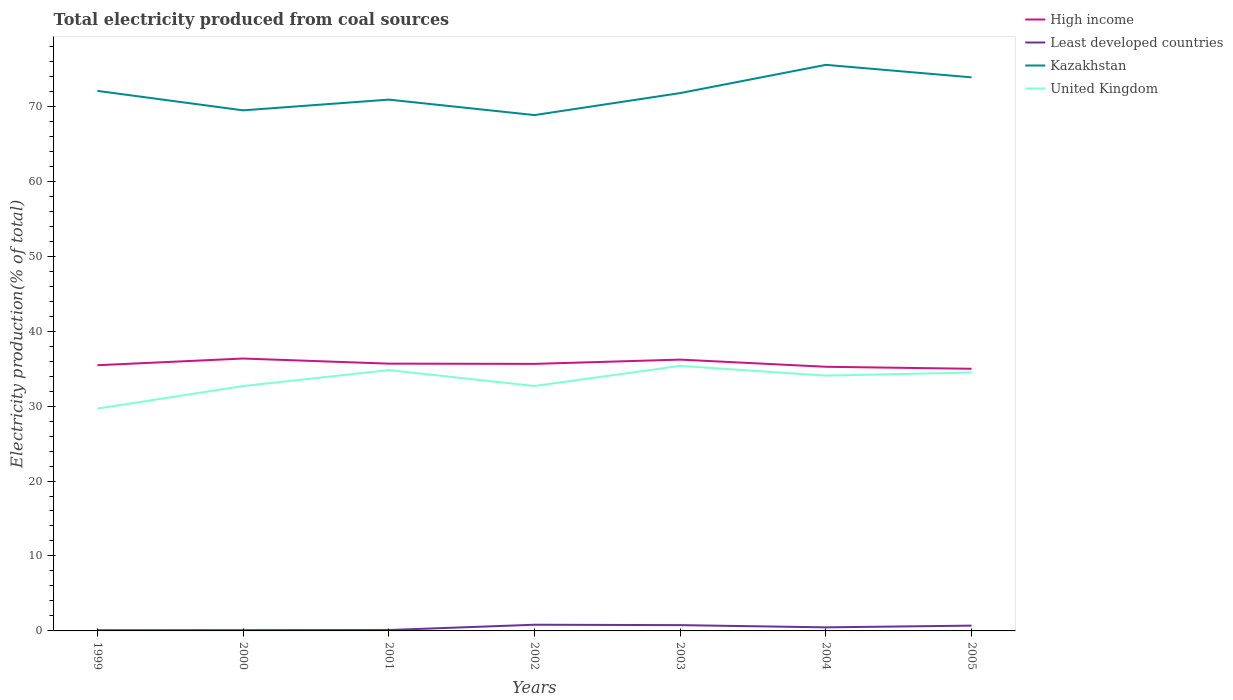How many different coloured lines are there?
Provide a short and direct response. 4. Across all years, what is the maximum total electricity produced in Kazakhstan?
Give a very brief answer. 68.82. What is the total total electricity produced in Kazakhstan in the graph?
Offer a terse response. -0.87. What is the difference between the highest and the second highest total electricity produced in Kazakhstan?
Provide a short and direct response. 6.7. What is the difference between two consecutive major ticks on the Y-axis?
Ensure brevity in your answer.  10. Does the graph contain any zero values?
Keep it short and to the point. No. How many legend labels are there?
Keep it short and to the point. 4. What is the title of the graph?
Ensure brevity in your answer.  Total electricity produced from coal sources. Does "Mozambique" appear as one of the legend labels in the graph?
Ensure brevity in your answer.  No. What is the label or title of the X-axis?
Your answer should be very brief. Years. What is the Electricity production(% of total) of High income in 1999?
Make the answer very short. 35.45. What is the Electricity production(% of total) in Least developed countries in 1999?
Your answer should be compact. 0.1. What is the Electricity production(% of total) in Kazakhstan in 1999?
Your answer should be compact. 72.05. What is the Electricity production(% of total) in United Kingdom in 1999?
Your answer should be compact. 29.66. What is the Electricity production(% of total) in High income in 2000?
Your answer should be compact. 36.34. What is the Electricity production(% of total) of Least developed countries in 2000?
Your answer should be compact. 0.1. What is the Electricity production(% of total) of Kazakhstan in 2000?
Give a very brief answer. 69.45. What is the Electricity production(% of total) in United Kingdom in 2000?
Provide a short and direct response. 32.67. What is the Electricity production(% of total) in High income in 2001?
Keep it short and to the point. 35.66. What is the Electricity production(% of total) of Least developed countries in 2001?
Make the answer very short. 0.12. What is the Electricity production(% of total) in Kazakhstan in 2001?
Your answer should be very brief. 70.88. What is the Electricity production(% of total) in United Kingdom in 2001?
Your response must be concise. 34.8. What is the Electricity production(% of total) of High income in 2002?
Your answer should be very brief. 35.63. What is the Electricity production(% of total) in Least developed countries in 2002?
Provide a succinct answer. 0.83. What is the Electricity production(% of total) of Kazakhstan in 2002?
Make the answer very short. 68.82. What is the Electricity production(% of total) in United Kingdom in 2002?
Ensure brevity in your answer.  32.68. What is the Electricity production(% of total) in High income in 2003?
Ensure brevity in your answer.  36.2. What is the Electricity production(% of total) in Least developed countries in 2003?
Offer a very short reply. 0.77. What is the Electricity production(% of total) in Kazakhstan in 2003?
Your response must be concise. 71.75. What is the Electricity production(% of total) of United Kingdom in 2003?
Your answer should be compact. 35.36. What is the Electricity production(% of total) of High income in 2004?
Offer a terse response. 35.24. What is the Electricity production(% of total) of Least developed countries in 2004?
Offer a very short reply. 0.48. What is the Electricity production(% of total) of Kazakhstan in 2004?
Provide a short and direct response. 75.52. What is the Electricity production(% of total) in United Kingdom in 2004?
Your response must be concise. 34.06. What is the Electricity production(% of total) of High income in 2005?
Keep it short and to the point. 34.97. What is the Electricity production(% of total) in Least developed countries in 2005?
Your answer should be compact. 0.71. What is the Electricity production(% of total) of Kazakhstan in 2005?
Your answer should be very brief. 73.85. What is the Electricity production(% of total) of United Kingdom in 2005?
Offer a terse response. 34.48. Across all years, what is the maximum Electricity production(% of total) in High income?
Ensure brevity in your answer.  36.34. Across all years, what is the maximum Electricity production(% of total) of Least developed countries?
Your answer should be very brief. 0.83. Across all years, what is the maximum Electricity production(% of total) of Kazakhstan?
Make the answer very short. 75.52. Across all years, what is the maximum Electricity production(% of total) in United Kingdom?
Give a very brief answer. 35.36. Across all years, what is the minimum Electricity production(% of total) in High income?
Ensure brevity in your answer.  34.97. Across all years, what is the minimum Electricity production(% of total) of Least developed countries?
Ensure brevity in your answer.  0.1. Across all years, what is the minimum Electricity production(% of total) in Kazakhstan?
Your answer should be very brief. 68.82. Across all years, what is the minimum Electricity production(% of total) of United Kingdom?
Your answer should be very brief. 29.66. What is the total Electricity production(% of total) of High income in the graph?
Keep it short and to the point. 249.48. What is the total Electricity production(% of total) of Least developed countries in the graph?
Make the answer very short. 3.1. What is the total Electricity production(% of total) of Kazakhstan in the graph?
Your answer should be compact. 502.33. What is the total Electricity production(% of total) in United Kingdom in the graph?
Give a very brief answer. 233.7. What is the difference between the Electricity production(% of total) in High income in 1999 and that in 2000?
Offer a terse response. -0.89. What is the difference between the Electricity production(% of total) of Least developed countries in 1999 and that in 2000?
Give a very brief answer. -0.01. What is the difference between the Electricity production(% of total) of Kazakhstan in 1999 and that in 2000?
Your answer should be very brief. 2.6. What is the difference between the Electricity production(% of total) of United Kingdom in 1999 and that in 2000?
Offer a very short reply. -3.01. What is the difference between the Electricity production(% of total) of High income in 1999 and that in 2001?
Give a very brief answer. -0.21. What is the difference between the Electricity production(% of total) of Least developed countries in 1999 and that in 2001?
Offer a very short reply. -0.02. What is the difference between the Electricity production(% of total) of Kazakhstan in 1999 and that in 2001?
Offer a very short reply. 1.17. What is the difference between the Electricity production(% of total) of United Kingdom in 1999 and that in 2001?
Ensure brevity in your answer.  -5.13. What is the difference between the Electricity production(% of total) of High income in 1999 and that in 2002?
Provide a succinct answer. -0.18. What is the difference between the Electricity production(% of total) in Least developed countries in 1999 and that in 2002?
Keep it short and to the point. -0.73. What is the difference between the Electricity production(% of total) of Kazakhstan in 1999 and that in 2002?
Your response must be concise. 3.23. What is the difference between the Electricity production(% of total) of United Kingdom in 1999 and that in 2002?
Your answer should be very brief. -3.02. What is the difference between the Electricity production(% of total) in High income in 1999 and that in 2003?
Your answer should be compact. -0.75. What is the difference between the Electricity production(% of total) in Least developed countries in 1999 and that in 2003?
Your answer should be compact. -0.68. What is the difference between the Electricity production(% of total) in Kazakhstan in 1999 and that in 2003?
Make the answer very short. 0.29. What is the difference between the Electricity production(% of total) in United Kingdom in 1999 and that in 2003?
Provide a succinct answer. -5.7. What is the difference between the Electricity production(% of total) in High income in 1999 and that in 2004?
Keep it short and to the point. 0.21. What is the difference between the Electricity production(% of total) of Least developed countries in 1999 and that in 2004?
Provide a short and direct response. -0.38. What is the difference between the Electricity production(% of total) of Kazakhstan in 1999 and that in 2004?
Your answer should be very brief. -3.47. What is the difference between the Electricity production(% of total) of United Kingdom in 1999 and that in 2004?
Provide a succinct answer. -4.4. What is the difference between the Electricity production(% of total) of High income in 1999 and that in 2005?
Your answer should be very brief. 0.48. What is the difference between the Electricity production(% of total) of Least developed countries in 1999 and that in 2005?
Your answer should be very brief. -0.61. What is the difference between the Electricity production(% of total) in Kazakhstan in 1999 and that in 2005?
Offer a terse response. -1.81. What is the difference between the Electricity production(% of total) in United Kingdom in 1999 and that in 2005?
Your answer should be compact. -4.82. What is the difference between the Electricity production(% of total) in High income in 2000 and that in 2001?
Your answer should be very brief. 0.68. What is the difference between the Electricity production(% of total) in Least developed countries in 2000 and that in 2001?
Make the answer very short. -0.02. What is the difference between the Electricity production(% of total) of Kazakhstan in 2000 and that in 2001?
Offer a very short reply. -1.43. What is the difference between the Electricity production(% of total) of United Kingdom in 2000 and that in 2001?
Your answer should be very brief. -2.13. What is the difference between the Electricity production(% of total) in High income in 2000 and that in 2002?
Give a very brief answer. 0.71. What is the difference between the Electricity production(% of total) of Least developed countries in 2000 and that in 2002?
Your answer should be compact. -0.72. What is the difference between the Electricity production(% of total) of Kazakhstan in 2000 and that in 2002?
Ensure brevity in your answer.  0.63. What is the difference between the Electricity production(% of total) in United Kingdom in 2000 and that in 2002?
Provide a short and direct response. -0.01. What is the difference between the Electricity production(% of total) in High income in 2000 and that in 2003?
Offer a very short reply. 0.14. What is the difference between the Electricity production(% of total) in Least developed countries in 2000 and that in 2003?
Your answer should be compact. -0.67. What is the difference between the Electricity production(% of total) of Kazakhstan in 2000 and that in 2003?
Provide a succinct answer. -2.3. What is the difference between the Electricity production(% of total) in United Kingdom in 2000 and that in 2003?
Make the answer very short. -2.69. What is the difference between the Electricity production(% of total) of High income in 2000 and that in 2004?
Make the answer very short. 1.1. What is the difference between the Electricity production(% of total) of Least developed countries in 2000 and that in 2004?
Make the answer very short. -0.38. What is the difference between the Electricity production(% of total) in Kazakhstan in 2000 and that in 2004?
Provide a succinct answer. -6.07. What is the difference between the Electricity production(% of total) in United Kingdom in 2000 and that in 2004?
Provide a short and direct response. -1.39. What is the difference between the Electricity production(% of total) in High income in 2000 and that in 2005?
Your answer should be very brief. 1.37. What is the difference between the Electricity production(% of total) of Least developed countries in 2000 and that in 2005?
Provide a succinct answer. -0.61. What is the difference between the Electricity production(% of total) of Kazakhstan in 2000 and that in 2005?
Provide a succinct answer. -4.4. What is the difference between the Electricity production(% of total) in United Kingdom in 2000 and that in 2005?
Make the answer very short. -1.81. What is the difference between the Electricity production(% of total) of High income in 2001 and that in 2002?
Provide a succinct answer. 0.03. What is the difference between the Electricity production(% of total) of Least developed countries in 2001 and that in 2002?
Provide a short and direct response. -0.71. What is the difference between the Electricity production(% of total) in Kazakhstan in 2001 and that in 2002?
Provide a succinct answer. 2.06. What is the difference between the Electricity production(% of total) in United Kingdom in 2001 and that in 2002?
Make the answer very short. 2.12. What is the difference between the Electricity production(% of total) of High income in 2001 and that in 2003?
Give a very brief answer. -0.54. What is the difference between the Electricity production(% of total) of Least developed countries in 2001 and that in 2003?
Give a very brief answer. -0.65. What is the difference between the Electricity production(% of total) of Kazakhstan in 2001 and that in 2003?
Ensure brevity in your answer.  -0.87. What is the difference between the Electricity production(% of total) in United Kingdom in 2001 and that in 2003?
Ensure brevity in your answer.  -0.56. What is the difference between the Electricity production(% of total) of High income in 2001 and that in 2004?
Offer a terse response. 0.42. What is the difference between the Electricity production(% of total) in Least developed countries in 2001 and that in 2004?
Give a very brief answer. -0.36. What is the difference between the Electricity production(% of total) in Kazakhstan in 2001 and that in 2004?
Ensure brevity in your answer.  -4.64. What is the difference between the Electricity production(% of total) in United Kingdom in 2001 and that in 2004?
Ensure brevity in your answer.  0.74. What is the difference between the Electricity production(% of total) in High income in 2001 and that in 2005?
Offer a very short reply. 0.69. What is the difference between the Electricity production(% of total) in Least developed countries in 2001 and that in 2005?
Your answer should be compact. -0.59. What is the difference between the Electricity production(% of total) of Kazakhstan in 2001 and that in 2005?
Your answer should be very brief. -2.97. What is the difference between the Electricity production(% of total) of United Kingdom in 2001 and that in 2005?
Provide a succinct answer. 0.32. What is the difference between the Electricity production(% of total) of High income in 2002 and that in 2003?
Offer a terse response. -0.57. What is the difference between the Electricity production(% of total) in Least developed countries in 2002 and that in 2003?
Keep it short and to the point. 0.05. What is the difference between the Electricity production(% of total) in Kazakhstan in 2002 and that in 2003?
Give a very brief answer. -2.93. What is the difference between the Electricity production(% of total) of United Kingdom in 2002 and that in 2003?
Make the answer very short. -2.68. What is the difference between the Electricity production(% of total) in High income in 2002 and that in 2004?
Offer a terse response. 0.39. What is the difference between the Electricity production(% of total) in Least developed countries in 2002 and that in 2004?
Your answer should be very brief. 0.35. What is the difference between the Electricity production(% of total) of Kazakhstan in 2002 and that in 2004?
Ensure brevity in your answer.  -6.7. What is the difference between the Electricity production(% of total) in United Kingdom in 2002 and that in 2004?
Make the answer very short. -1.38. What is the difference between the Electricity production(% of total) in High income in 2002 and that in 2005?
Make the answer very short. 0.66. What is the difference between the Electricity production(% of total) in Least developed countries in 2002 and that in 2005?
Make the answer very short. 0.12. What is the difference between the Electricity production(% of total) in Kazakhstan in 2002 and that in 2005?
Offer a very short reply. -5.03. What is the difference between the Electricity production(% of total) of United Kingdom in 2002 and that in 2005?
Your response must be concise. -1.8. What is the difference between the Electricity production(% of total) of High income in 2003 and that in 2004?
Your answer should be very brief. 0.95. What is the difference between the Electricity production(% of total) in Least developed countries in 2003 and that in 2004?
Provide a short and direct response. 0.3. What is the difference between the Electricity production(% of total) in Kazakhstan in 2003 and that in 2004?
Your answer should be very brief. -3.77. What is the difference between the Electricity production(% of total) of United Kingdom in 2003 and that in 2004?
Your response must be concise. 1.3. What is the difference between the Electricity production(% of total) of High income in 2003 and that in 2005?
Provide a short and direct response. 1.22. What is the difference between the Electricity production(% of total) of Least developed countries in 2003 and that in 2005?
Offer a very short reply. 0.07. What is the difference between the Electricity production(% of total) of Kazakhstan in 2003 and that in 2005?
Make the answer very short. -2.1. What is the difference between the Electricity production(% of total) in United Kingdom in 2003 and that in 2005?
Provide a short and direct response. 0.88. What is the difference between the Electricity production(% of total) in High income in 2004 and that in 2005?
Provide a short and direct response. 0.27. What is the difference between the Electricity production(% of total) in Least developed countries in 2004 and that in 2005?
Offer a terse response. -0.23. What is the difference between the Electricity production(% of total) of Kazakhstan in 2004 and that in 2005?
Provide a succinct answer. 1.67. What is the difference between the Electricity production(% of total) of United Kingdom in 2004 and that in 2005?
Make the answer very short. -0.42. What is the difference between the Electricity production(% of total) in High income in 1999 and the Electricity production(% of total) in Least developed countries in 2000?
Your answer should be very brief. 35.35. What is the difference between the Electricity production(% of total) of High income in 1999 and the Electricity production(% of total) of Kazakhstan in 2000?
Keep it short and to the point. -34. What is the difference between the Electricity production(% of total) in High income in 1999 and the Electricity production(% of total) in United Kingdom in 2000?
Provide a short and direct response. 2.78. What is the difference between the Electricity production(% of total) of Least developed countries in 1999 and the Electricity production(% of total) of Kazakhstan in 2000?
Make the answer very short. -69.35. What is the difference between the Electricity production(% of total) in Least developed countries in 1999 and the Electricity production(% of total) in United Kingdom in 2000?
Offer a terse response. -32.57. What is the difference between the Electricity production(% of total) in Kazakhstan in 1999 and the Electricity production(% of total) in United Kingdom in 2000?
Ensure brevity in your answer.  39.38. What is the difference between the Electricity production(% of total) in High income in 1999 and the Electricity production(% of total) in Least developed countries in 2001?
Your answer should be very brief. 35.33. What is the difference between the Electricity production(% of total) in High income in 1999 and the Electricity production(% of total) in Kazakhstan in 2001?
Your answer should be compact. -35.43. What is the difference between the Electricity production(% of total) in High income in 1999 and the Electricity production(% of total) in United Kingdom in 2001?
Offer a very short reply. 0.65. What is the difference between the Electricity production(% of total) of Least developed countries in 1999 and the Electricity production(% of total) of Kazakhstan in 2001?
Your response must be concise. -70.78. What is the difference between the Electricity production(% of total) of Least developed countries in 1999 and the Electricity production(% of total) of United Kingdom in 2001?
Offer a terse response. -34.7. What is the difference between the Electricity production(% of total) of Kazakhstan in 1999 and the Electricity production(% of total) of United Kingdom in 2001?
Offer a terse response. 37.25. What is the difference between the Electricity production(% of total) of High income in 1999 and the Electricity production(% of total) of Least developed countries in 2002?
Make the answer very short. 34.62. What is the difference between the Electricity production(% of total) of High income in 1999 and the Electricity production(% of total) of Kazakhstan in 2002?
Your answer should be very brief. -33.37. What is the difference between the Electricity production(% of total) in High income in 1999 and the Electricity production(% of total) in United Kingdom in 2002?
Offer a terse response. 2.77. What is the difference between the Electricity production(% of total) of Least developed countries in 1999 and the Electricity production(% of total) of Kazakhstan in 2002?
Give a very brief answer. -68.72. What is the difference between the Electricity production(% of total) of Least developed countries in 1999 and the Electricity production(% of total) of United Kingdom in 2002?
Your response must be concise. -32.58. What is the difference between the Electricity production(% of total) in Kazakhstan in 1999 and the Electricity production(% of total) in United Kingdom in 2002?
Your response must be concise. 39.37. What is the difference between the Electricity production(% of total) of High income in 1999 and the Electricity production(% of total) of Least developed countries in 2003?
Your answer should be compact. 34.67. What is the difference between the Electricity production(% of total) in High income in 1999 and the Electricity production(% of total) in Kazakhstan in 2003?
Your response must be concise. -36.31. What is the difference between the Electricity production(% of total) in High income in 1999 and the Electricity production(% of total) in United Kingdom in 2003?
Give a very brief answer. 0.09. What is the difference between the Electricity production(% of total) of Least developed countries in 1999 and the Electricity production(% of total) of Kazakhstan in 2003?
Give a very brief answer. -71.66. What is the difference between the Electricity production(% of total) in Least developed countries in 1999 and the Electricity production(% of total) in United Kingdom in 2003?
Provide a short and direct response. -35.26. What is the difference between the Electricity production(% of total) in Kazakhstan in 1999 and the Electricity production(% of total) in United Kingdom in 2003?
Your answer should be very brief. 36.69. What is the difference between the Electricity production(% of total) of High income in 1999 and the Electricity production(% of total) of Least developed countries in 2004?
Give a very brief answer. 34.97. What is the difference between the Electricity production(% of total) in High income in 1999 and the Electricity production(% of total) in Kazakhstan in 2004?
Your answer should be compact. -40.07. What is the difference between the Electricity production(% of total) of High income in 1999 and the Electricity production(% of total) of United Kingdom in 2004?
Offer a very short reply. 1.39. What is the difference between the Electricity production(% of total) of Least developed countries in 1999 and the Electricity production(% of total) of Kazakhstan in 2004?
Keep it short and to the point. -75.43. What is the difference between the Electricity production(% of total) in Least developed countries in 1999 and the Electricity production(% of total) in United Kingdom in 2004?
Ensure brevity in your answer.  -33.96. What is the difference between the Electricity production(% of total) of Kazakhstan in 1999 and the Electricity production(% of total) of United Kingdom in 2004?
Give a very brief answer. 37.99. What is the difference between the Electricity production(% of total) in High income in 1999 and the Electricity production(% of total) in Least developed countries in 2005?
Offer a terse response. 34.74. What is the difference between the Electricity production(% of total) in High income in 1999 and the Electricity production(% of total) in Kazakhstan in 2005?
Provide a short and direct response. -38.41. What is the difference between the Electricity production(% of total) in High income in 1999 and the Electricity production(% of total) in United Kingdom in 2005?
Provide a short and direct response. 0.97. What is the difference between the Electricity production(% of total) of Least developed countries in 1999 and the Electricity production(% of total) of Kazakhstan in 2005?
Ensure brevity in your answer.  -73.76. What is the difference between the Electricity production(% of total) of Least developed countries in 1999 and the Electricity production(% of total) of United Kingdom in 2005?
Make the answer very short. -34.38. What is the difference between the Electricity production(% of total) in Kazakhstan in 1999 and the Electricity production(% of total) in United Kingdom in 2005?
Your response must be concise. 37.57. What is the difference between the Electricity production(% of total) in High income in 2000 and the Electricity production(% of total) in Least developed countries in 2001?
Make the answer very short. 36.22. What is the difference between the Electricity production(% of total) of High income in 2000 and the Electricity production(% of total) of Kazakhstan in 2001?
Keep it short and to the point. -34.54. What is the difference between the Electricity production(% of total) of High income in 2000 and the Electricity production(% of total) of United Kingdom in 2001?
Make the answer very short. 1.54. What is the difference between the Electricity production(% of total) in Least developed countries in 2000 and the Electricity production(% of total) in Kazakhstan in 2001?
Your answer should be very brief. -70.78. What is the difference between the Electricity production(% of total) in Least developed countries in 2000 and the Electricity production(% of total) in United Kingdom in 2001?
Offer a terse response. -34.69. What is the difference between the Electricity production(% of total) of Kazakhstan in 2000 and the Electricity production(% of total) of United Kingdom in 2001?
Keep it short and to the point. 34.66. What is the difference between the Electricity production(% of total) in High income in 2000 and the Electricity production(% of total) in Least developed countries in 2002?
Make the answer very short. 35.51. What is the difference between the Electricity production(% of total) of High income in 2000 and the Electricity production(% of total) of Kazakhstan in 2002?
Your response must be concise. -32.48. What is the difference between the Electricity production(% of total) of High income in 2000 and the Electricity production(% of total) of United Kingdom in 2002?
Ensure brevity in your answer.  3.66. What is the difference between the Electricity production(% of total) in Least developed countries in 2000 and the Electricity production(% of total) in Kazakhstan in 2002?
Your answer should be compact. -68.72. What is the difference between the Electricity production(% of total) of Least developed countries in 2000 and the Electricity production(% of total) of United Kingdom in 2002?
Your answer should be very brief. -32.58. What is the difference between the Electricity production(% of total) in Kazakhstan in 2000 and the Electricity production(% of total) in United Kingdom in 2002?
Provide a short and direct response. 36.77. What is the difference between the Electricity production(% of total) in High income in 2000 and the Electricity production(% of total) in Least developed countries in 2003?
Provide a succinct answer. 35.57. What is the difference between the Electricity production(% of total) in High income in 2000 and the Electricity production(% of total) in Kazakhstan in 2003?
Your answer should be compact. -35.42. What is the difference between the Electricity production(% of total) of High income in 2000 and the Electricity production(% of total) of United Kingdom in 2003?
Keep it short and to the point. 0.98. What is the difference between the Electricity production(% of total) of Least developed countries in 2000 and the Electricity production(% of total) of Kazakhstan in 2003?
Your response must be concise. -71.65. What is the difference between the Electricity production(% of total) of Least developed countries in 2000 and the Electricity production(% of total) of United Kingdom in 2003?
Ensure brevity in your answer.  -35.26. What is the difference between the Electricity production(% of total) of Kazakhstan in 2000 and the Electricity production(% of total) of United Kingdom in 2003?
Your answer should be compact. 34.09. What is the difference between the Electricity production(% of total) in High income in 2000 and the Electricity production(% of total) in Least developed countries in 2004?
Offer a very short reply. 35.86. What is the difference between the Electricity production(% of total) of High income in 2000 and the Electricity production(% of total) of Kazakhstan in 2004?
Offer a terse response. -39.18. What is the difference between the Electricity production(% of total) in High income in 2000 and the Electricity production(% of total) in United Kingdom in 2004?
Your answer should be compact. 2.28. What is the difference between the Electricity production(% of total) in Least developed countries in 2000 and the Electricity production(% of total) in Kazakhstan in 2004?
Provide a short and direct response. -75.42. What is the difference between the Electricity production(% of total) in Least developed countries in 2000 and the Electricity production(% of total) in United Kingdom in 2004?
Provide a succinct answer. -33.96. What is the difference between the Electricity production(% of total) in Kazakhstan in 2000 and the Electricity production(% of total) in United Kingdom in 2004?
Make the answer very short. 35.39. What is the difference between the Electricity production(% of total) in High income in 2000 and the Electricity production(% of total) in Least developed countries in 2005?
Offer a very short reply. 35.63. What is the difference between the Electricity production(% of total) of High income in 2000 and the Electricity production(% of total) of Kazakhstan in 2005?
Your response must be concise. -37.51. What is the difference between the Electricity production(% of total) in High income in 2000 and the Electricity production(% of total) in United Kingdom in 2005?
Your answer should be compact. 1.86. What is the difference between the Electricity production(% of total) in Least developed countries in 2000 and the Electricity production(% of total) in Kazakhstan in 2005?
Provide a short and direct response. -73.75. What is the difference between the Electricity production(% of total) of Least developed countries in 2000 and the Electricity production(% of total) of United Kingdom in 2005?
Give a very brief answer. -34.38. What is the difference between the Electricity production(% of total) of Kazakhstan in 2000 and the Electricity production(% of total) of United Kingdom in 2005?
Provide a succinct answer. 34.97. What is the difference between the Electricity production(% of total) of High income in 2001 and the Electricity production(% of total) of Least developed countries in 2002?
Your answer should be compact. 34.83. What is the difference between the Electricity production(% of total) of High income in 2001 and the Electricity production(% of total) of Kazakhstan in 2002?
Provide a short and direct response. -33.16. What is the difference between the Electricity production(% of total) of High income in 2001 and the Electricity production(% of total) of United Kingdom in 2002?
Offer a very short reply. 2.98. What is the difference between the Electricity production(% of total) in Least developed countries in 2001 and the Electricity production(% of total) in Kazakhstan in 2002?
Make the answer very short. -68.7. What is the difference between the Electricity production(% of total) in Least developed countries in 2001 and the Electricity production(% of total) in United Kingdom in 2002?
Provide a succinct answer. -32.56. What is the difference between the Electricity production(% of total) in Kazakhstan in 2001 and the Electricity production(% of total) in United Kingdom in 2002?
Provide a short and direct response. 38.2. What is the difference between the Electricity production(% of total) of High income in 2001 and the Electricity production(% of total) of Least developed countries in 2003?
Provide a succinct answer. 34.89. What is the difference between the Electricity production(% of total) of High income in 2001 and the Electricity production(% of total) of Kazakhstan in 2003?
Offer a terse response. -36.1. What is the difference between the Electricity production(% of total) in High income in 2001 and the Electricity production(% of total) in United Kingdom in 2003?
Offer a terse response. 0.3. What is the difference between the Electricity production(% of total) of Least developed countries in 2001 and the Electricity production(% of total) of Kazakhstan in 2003?
Keep it short and to the point. -71.63. What is the difference between the Electricity production(% of total) of Least developed countries in 2001 and the Electricity production(% of total) of United Kingdom in 2003?
Ensure brevity in your answer.  -35.24. What is the difference between the Electricity production(% of total) in Kazakhstan in 2001 and the Electricity production(% of total) in United Kingdom in 2003?
Ensure brevity in your answer.  35.52. What is the difference between the Electricity production(% of total) in High income in 2001 and the Electricity production(% of total) in Least developed countries in 2004?
Provide a succinct answer. 35.18. What is the difference between the Electricity production(% of total) in High income in 2001 and the Electricity production(% of total) in Kazakhstan in 2004?
Ensure brevity in your answer.  -39.86. What is the difference between the Electricity production(% of total) of High income in 2001 and the Electricity production(% of total) of United Kingdom in 2004?
Make the answer very short. 1.6. What is the difference between the Electricity production(% of total) in Least developed countries in 2001 and the Electricity production(% of total) in Kazakhstan in 2004?
Offer a terse response. -75.4. What is the difference between the Electricity production(% of total) in Least developed countries in 2001 and the Electricity production(% of total) in United Kingdom in 2004?
Your answer should be very brief. -33.94. What is the difference between the Electricity production(% of total) of Kazakhstan in 2001 and the Electricity production(% of total) of United Kingdom in 2004?
Provide a succinct answer. 36.82. What is the difference between the Electricity production(% of total) in High income in 2001 and the Electricity production(% of total) in Least developed countries in 2005?
Your answer should be compact. 34.95. What is the difference between the Electricity production(% of total) of High income in 2001 and the Electricity production(% of total) of Kazakhstan in 2005?
Provide a short and direct response. -38.19. What is the difference between the Electricity production(% of total) in High income in 2001 and the Electricity production(% of total) in United Kingdom in 2005?
Your answer should be very brief. 1.18. What is the difference between the Electricity production(% of total) of Least developed countries in 2001 and the Electricity production(% of total) of Kazakhstan in 2005?
Your response must be concise. -73.73. What is the difference between the Electricity production(% of total) in Least developed countries in 2001 and the Electricity production(% of total) in United Kingdom in 2005?
Your answer should be very brief. -34.36. What is the difference between the Electricity production(% of total) in Kazakhstan in 2001 and the Electricity production(% of total) in United Kingdom in 2005?
Keep it short and to the point. 36.4. What is the difference between the Electricity production(% of total) in High income in 2002 and the Electricity production(% of total) in Least developed countries in 2003?
Provide a succinct answer. 34.85. What is the difference between the Electricity production(% of total) of High income in 2002 and the Electricity production(% of total) of Kazakhstan in 2003?
Offer a very short reply. -36.13. What is the difference between the Electricity production(% of total) of High income in 2002 and the Electricity production(% of total) of United Kingdom in 2003?
Provide a succinct answer. 0.27. What is the difference between the Electricity production(% of total) in Least developed countries in 2002 and the Electricity production(% of total) in Kazakhstan in 2003?
Offer a very short reply. -70.93. What is the difference between the Electricity production(% of total) in Least developed countries in 2002 and the Electricity production(% of total) in United Kingdom in 2003?
Your answer should be very brief. -34.53. What is the difference between the Electricity production(% of total) in Kazakhstan in 2002 and the Electricity production(% of total) in United Kingdom in 2003?
Your answer should be very brief. 33.46. What is the difference between the Electricity production(% of total) of High income in 2002 and the Electricity production(% of total) of Least developed countries in 2004?
Provide a short and direct response. 35.15. What is the difference between the Electricity production(% of total) of High income in 2002 and the Electricity production(% of total) of Kazakhstan in 2004?
Ensure brevity in your answer.  -39.89. What is the difference between the Electricity production(% of total) of High income in 2002 and the Electricity production(% of total) of United Kingdom in 2004?
Offer a very short reply. 1.57. What is the difference between the Electricity production(% of total) in Least developed countries in 2002 and the Electricity production(% of total) in Kazakhstan in 2004?
Offer a terse response. -74.7. What is the difference between the Electricity production(% of total) in Least developed countries in 2002 and the Electricity production(% of total) in United Kingdom in 2004?
Offer a terse response. -33.23. What is the difference between the Electricity production(% of total) of Kazakhstan in 2002 and the Electricity production(% of total) of United Kingdom in 2004?
Give a very brief answer. 34.76. What is the difference between the Electricity production(% of total) of High income in 2002 and the Electricity production(% of total) of Least developed countries in 2005?
Your answer should be compact. 34.92. What is the difference between the Electricity production(% of total) in High income in 2002 and the Electricity production(% of total) in Kazakhstan in 2005?
Give a very brief answer. -38.23. What is the difference between the Electricity production(% of total) of High income in 2002 and the Electricity production(% of total) of United Kingdom in 2005?
Offer a very short reply. 1.15. What is the difference between the Electricity production(% of total) in Least developed countries in 2002 and the Electricity production(% of total) in Kazakhstan in 2005?
Give a very brief answer. -73.03. What is the difference between the Electricity production(% of total) of Least developed countries in 2002 and the Electricity production(% of total) of United Kingdom in 2005?
Your answer should be compact. -33.65. What is the difference between the Electricity production(% of total) in Kazakhstan in 2002 and the Electricity production(% of total) in United Kingdom in 2005?
Your response must be concise. 34.34. What is the difference between the Electricity production(% of total) in High income in 2003 and the Electricity production(% of total) in Least developed countries in 2004?
Provide a short and direct response. 35.72. What is the difference between the Electricity production(% of total) in High income in 2003 and the Electricity production(% of total) in Kazakhstan in 2004?
Your answer should be very brief. -39.33. What is the difference between the Electricity production(% of total) in High income in 2003 and the Electricity production(% of total) in United Kingdom in 2004?
Ensure brevity in your answer.  2.14. What is the difference between the Electricity production(% of total) of Least developed countries in 2003 and the Electricity production(% of total) of Kazakhstan in 2004?
Provide a short and direct response. -74.75. What is the difference between the Electricity production(% of total) in Least developed countries in 2003 and the Electricity production(% of total) in United Kingdom in 2004?
Offer a terse response. -33.29. What is the difference between the Electricity production(% of total) of Kazakhstan in 2003 and the Electricity production(% of total) of United Kingdom in 2004?
Provide a short and direct response. 37.7. What is the difference between the Electricity production(% of total) of High income in 2003 and the Electricity production(% of total) of Least developed countries in 2005?
Provide a succinct answer. 35.49. What is the difference between the Electricity production(% of total) of High income in 2003 and the Electricity production(% of total) of Kazakhstan in 2005?
Keep it short and to the point. -37.66. What is the difference between the Electricity production(% of total) in High income in 2003 and the Electricity production(% of total) in United Kingdom in 2005?
Your answer should be very brief. 1.72. What is the difference between the Electricity production(% of total) of Least developed countries in 2003 and the Electricity production(% of total) of Kazakhstan in 2005?
Offer a terse response. -73.08. What is the difference between the Electricity production(% of total) of Least developed countries in 2003 and the Electricity production(% of total) of United Kingdom in 2005?
Offer a terse response. -33.7. What is the difference between the Electricity production(% of total) of Kazakhstan in 2003 and the Electricity production(% of total) of United Kingdom in 2005?
Your response must be concise. 37.28. What is the difference between the Electricity production(% of total) of High income in 2004 and the Electricity production(% of total) of Least developed countries in 2005?
Keep it short and to the point. 34.53. What is the difference between the Electricity production(% of total) in High income in 2004 and the Electricity production(% of total) in Kazakhstan in 2005?
Your answer should be compact. -38.61. What is the difference between the Electricity production(% of total) of High income in 2004 and the Electricity production(% of total) of United Kingdom in 2005?
Provide a succinct answer. 0.76. What is the difference between the Electricity production(% of total) of Least developed countries in 2004 and the Electricity production(% of total) of Kazakhstan in 2005?
Give a very brief answer. -73.38. What is the difference between the Electricity production(% of total) in Least developed countries in 2004 and the Electricity production(% of total) in United Kingdom in 2005?
Keep it short and to the point. -34. What is the difference between the Electricity production(% of total) in Kazakhstan in 2004 and the Electricity production(% of total) in United Kingdom in 2005?
Offer a very short reply. 41.04. What is the average Electricity production(% of total) of High income per year?
Give a very brief answer. 35.64. What is the average Electricity production(% of total) in Least developed countries per year?
Provide a short and direct response. 0.44. What is the average Electricity production(% of total) of Kazakhstan per year?
Keep it short and to the point. 71.76. What is the average Electricity production(% of total) of United Kingdom per year?
Provide a short and direct response. 33.39. In the year 1999, what is the difference between the Electricity production(% of total) in High income and Electricity production(% of total) in Least developed countries?
Provide a short and direct response. 35.35. In the year 1999, what is the difference between the Electricity production(% of total) of High income and Electricity production(% of total) of Kazakhstan?
Offer a terse response. -36.6. In the year 1999, what is the difference between the Electricity production(% of total) of High income and Electricity production(% of total) of United Kingdom?
Offer a very short reply. 5.79. In the year 1999, what is the difference between the Electricity production(% of total) of Least developed countries and Electricity production(% of total) of Kazakhstan?
Ensure brevity in your answer.  -71.95. In the year 1999, what is the difference between the Electricity production(% of total) of Least developed countries and Electricity production(% of total) of United Kingdom?
Ensure brevity in your answer.  -29.57. In the year 1999, what is the difference between the Electricity production(% of total) in Kazakhstan and Electricity production(% of total) in United Kingdom?
Your answer should be compact. 42.39. In the year 2000, what is the difference between the Electricity production(% of total) in High income and Electricity production(% of total) in Least developed countries?
Give a very brief answer. 36.24. In the year 2000, what is the difference between the Electricity production(% of total) of High income and Electricity production(% of total) of Kazakhstan?
Provide a short and direct response. -33.11. In the year 2000, what is the difference between the Electricity production(% of total) in High income and Electricity production(% of total) in United Kingdom?
Offer a terse response. 3.67. In the year 2000, what is the difference between the Electricity production(% of total) in Least developed countries and Electricity production(% of total) in Kazakhstan?
Your answer should be compact. -69.35. In the year 2000, what is the difference between the Electricity production(% of total) of Least developed countries and Electricity production(% of total) of United Kingdom?
Provide a short and direct response. -32.57. In the year 2000, what is the difference between the Electricity production(% of total) in Kazakhstan and Electricity production(% of total) in United Kingdom?
Ensure brevity in your answer.  36.78. In the year 2001, what is the difference between the Electricity production(% of total) in High income and Electricity production(% of total) in Least developed countries?
Your answer should be very brief. 35.54. In the year 2001, what is the difference between the Electricity production(% of total) in High income and Electricity production(% of total) in Kazakhstan?
Your response must be concise. -35.22. In the year 2001, what is the difference between the Electricity production(% of total) in High income and Electricity production(% of total) in United Kingdom?
Make the answer very short. 0.86. In the year 2001, what is the difference between the Electricity production(% of total) of Least developed countries and Electricity production(% of total) of Kazakhstan?
Offer a very short reply. -70.76. In the year 2001, what is the difference between the Electricity production(% of total) in Least developed countries and Electricity production(% of total) in United Kingdom?
Offer a very short reply. -34.67. In the year 2001, what is the difference between the Electricity production(% of total) of Kazakhstan and Electricity production(% of total) of United Kingdom?
Offer a very short reply. 36.09. In the year 2002, what is the difference between the Electricity production(% of total) of High income and Electricity production(% of total) of Least developed countries?
Offer a terse response. 34.8. In the year 2002, what is the difference between the Electricity production(% of total) of High income and Electricity production(% of total) of Kazakhstan?
Your answer should be compact. -33.19. In the year 2002, what is the difference between the Electricity production(% of total) in High income and Electricity production(% of total) in United Kingdom?
Make the answer very short. 2.95. In the year 2002, what is the difference between the Electricity production(% of total) in Least developed countries and Electricity production(% of total) in Kazakhstan?
Provide a succinct answer. -67.99. In the year 2002, what is the difference between the Electricity production(% of total) of Least developed countries and Electricity production(% of total) of United Kingdom?
Make the answer very short. -31.85. In the year 2002, what is the difference between the Electricity production(% of total) of Kazakhstan and Electricity production(% of total) of United Kingdom?
Keep it short and to the point. 36.14. In the year 2003, what is the difference between the Electricity production(% of total) of High income and Electricity production(% of total) of Least developed countries?
Offer a very short reply. 35.42. In the year 2003, what is the difference between the Electricity production(% of total) of High income and Electricity production(% of total) of Kazakhstan?
Your answer should be very brief. -35.56. In the year 2003, what is the difference between the Electricity production(% of total) in High income and Electricity production(% of total) in United Kingdom?
Provide a short and direct response. 0.84. In the year 2003, what is the difference between the Electricity production(% of total) in Least developed countries and Electricity production(% of total) in Kazakhstan?
Offer a very short reply. -70.98. In the year 2003, what is the difference between the Electricity production(% of total) in Least developed countries and Electricity production(% of total) in United Kingdom?
Your answer should be very brief. -34.59. In the year 2003, what is the difference between the Electricity production(% of total) of Kazakhstan and Electricity production(% of total) of United Kingdom?
Give a very brief answer. 36.39. In the year 2004, what is the difference between the Electricity production(% of total) of High income and Electricity production(% of total) of Least developed countries?
Ensure brevity in your answer.  34.76. In the year 2004, what is the difference between the Electricity production(% of total) in High income and Electricity production(% of total) in Kazakhstan?
Provide a short and direct response. -40.28. In the year 2004, what is the difference between the Electricity production(% of total) of High income and Electricity production(% of total) of United Kingdom?
Your answer should be very brief. 1.18. In the year 2004, what is the difference between the Electricity production(% of total) in Least developed countries and Electricity production(% of total) in Kazakhstan?
Your answer should be very brief. -75.04. In the year 2004, what is the difference between the Electricity production(% of total) in Least developed countries and Electricity production(% of total) in United Kingdom?
Offer a terse response. -33.58. In the year 2004, what is the difference between the Electricity production(% of total) of Kazakhstan and Electricity production(% of total) of United Kingdom?
Ensure brevity in your answer.  41.46. In the year 2005, what is the difference between the Electricity production(% of total) of High income and Electricity production(% of total) of Least developed countries?
Provide a short and direct response. 34.26. In the year 2005, what is the difference between the Electricity production(% of total) in High income and Electricity production(% of total) in Kazakhstan?
Offer a very short reply. -38.88. In the year 2005, what is the difference between the Electricity production(% of total) in High income and Electricity production(% of total) in United Kingdom?
Your answer should be very brief. 0.49. In the year 2005, what is the difference between the Electricity production(% of total) of Least developed countries and Electricity production(% of total) of Kazakhstan?
Keep it short and to the point. -73.15. In the year 2005, what is the difference between the Electricity production(% of total) in Least developed countries and Electricity production(% of total) in United Kingdom?
Your response must be concise. -33.77. In the year 2005, what is the difference between the Electricity production(% of total) in Kazakhstan and Electricity production(% of total) in United Kingdom?
Ensure brevity in your answer.  39.37. What is the ratio of the Electricity production(% of total) in High income in 1999 to that in 2000?
Offer a very short reply. 0.98. What is the ratio of the Electricity production(% of total) of Least developed countries in 1999 to that in 2000?
Provide a short and direct response. 0.95. What is the ratio of the Electricity production(% of total) of Kazakhstan in 1999 to that in 2000?
Your response must be concise. 1.04. What is the ratio of the Electricity production(% of total) of United Kingdom in 1999 to that in 2000?
Your answer should be very brief. 0.91. What is the ratio of the Electricity production(% of total) of Least developed countries in 1999 to that in 2001?
Offer a very short reply. 0.8. What is the ratio of the Electricity production(% of total) in Kazakhstan in 1999 to that in 2001?
Give a very brief answer. 1.02. What is the ratio of the Electricity production(% of total) in United Kingdom in 1999 to that in 2001?
Keep it short and to the point. 0.85. What is the ratio of the Electricity production(% of total) of High income in 1999 to that in 2002?
Give a very brief answer. 0.99. What is the ratio of the Electricity production(% of total) of Least developed countries in 1999 to that in 2002?
Ensure brevity in your answer.  0.12. What is the ratio of the Electricity production(% of total) of Kazakhstan in 1999 to that in 2002?
Give a very brief answer. 1.05. What is the ratio of the Electricity production(% of total) of United Kingdom in 1999 to that in 2002?
Offer a very short reply. 0.91. What is the ratio of the Electricity production(% of total) in High income in 1999 to that in 2003?
Offer a terse response. 0.98. What is the ratio of the Electricity production(% of total) of Least developed countries in 1999 to that in 2003?
Your answer should be very brief. 0.12. What is the ratio of the Electricity production(% of total) of Kazakhstan in 1999 to that in 2003?
Offer a very short reply. 1. What is the ratio of the Electricity production(% of total) in United Kingdom in 1999 to that in 2003?
Ensure brevity in your answer.  0.84. What is the ratio of the Electricity production(% of total) of High income in 1999 to that in 2004?
Provide a succinct answer. 1.01. What is the ratio of the Electricity production(% of total) in Least developed countries in 1999 to that in 2004?
Give a very brief answer. 0.2. What is the ratio of the Electricity production(% of total) of Kazakhstan in 1999 to that in 2004?
Offer a very short reply. 0.95. What is the ratio of the Electricity production(% of total) in United Kingdom in 1999 to that in 2004?
Provide a short and direct response. 0.87. What is the ratio of the Electricity production(% of total) in High income in 1999 to that in 2005?
Provide a short and direct response. 1.01. What is the ratio of the Electricity production(% of total) of Least developed countries in 1999 to that in 2005?
Your response must be concise. 0.14. What is the ratio of the Electricity production(% of total) in Kazakhstan in 1999 to that in 2005?
Offer a terse response. 0.98. What is the ratio of the Electricity production(% of total) of United Kingdom in 1999 to that in 2005?
Your response must be concise. 0.86. What is the ratio of the Electricity production(% of total) in High income in 2000 to that in 2001?
Offer a terse response. 1.02. What is the ratio of the Electricity production(% of total) in Least developed countries in 2000 to that in 2001?
Keep it short and to the point. 0.84. What is the ratio of the Electricity production(% of total) of Kazakhstan in 2000 to that in 2001?
Your answer should be very brief. 0.98. What is the ratio of the Electricity production(% of total) in United Kingdom in 2000 to that in 2001?
Your answer should be very brief. 0.94. What is the ratio of the Electricity production(% of total) of High income in 2000 to that in 2002?
Offer a terse response. 1.02. What is the ratio of the Electricity production(% of total) in Least developed countries in 2000 to that in 2002?
Offer a very short reply. 0.12. What is the ratio of the Electricity production(% of total) of Kazakhstan in 2000 to that in 2002?
Your answer should be very brief. 1.01. What is the ratio of the Electricity production(% of total) in United Kingdom in 2000 to that in 2002?
Keep it short and to the point. 1. What is the ratio of the Electricity production(% of total) of Least developed countries in 2000 to that in 2003?
Your response must be concise. 0.13. What is the ratio of the Electricity production(% of total) of Kazakhstan in 2000 to that in 2003?
Provide a short and direct response. 0.97. What is the ratio of the Electricity production(% of total) of United Kingdom in 2000 to that in 2003?
Provide a short and direct response. 0.92. What is the ratio of the Electricity production(% of total) of High income in 2000 to that in 2004?
Your answer should be compact. 1.03. What is the ratio of the Electricity production(% of total) of Least developed countries in 2000 to that in 2004?
Your answer should be compact. 0.21. What is the ratio of the Electricity production(% of total) in Kazakhstan in 2000 to that in 2004?
Your answer should be very brief. 0.92. What is the ratio of the Electricity production(% of total) of United Kingdom in 2000 to that in 2004?
Your answer should be very brief. 0.96. What is the ratio of the Electricity production(% of total) of High income in 2000 to that in 2005?
Offer a terse response. 1.04. What is the ratio of the Electricity production(% of total) of Least developed countries in 2000 to that in 2005?
Keep it short and to the point. 0.14. What is the ratio of the Electricity production(% of total) of Kazakhstan in 2000 to that in 2005?
Your response must be concise. 0.94. What is the ratio of the Electricity production(% of total) in United Kingdom in 2000 to that in 2005?
Your answer should be very brief. 0.95. What is the ratio of the Electricity production(% of total) in Least developed countries in 2001 to that in 2002?
Keep it short and to the point. 0.15. What is the ratio of the Electricity production(% of total) in Kazakhstan in 2001 to that in 2002?
Offer a very short reply. 1.03. What is the ratio of the Electricity production(% of total) in United Kingdom in 2001 to that in 2002?
Make the answer very short. 1.06. What is the ratio of the Electricity production(% of total) of High income in 2001 to that in 2003?
Offer a terse response. 0.99. What is the ratio of the Electricity production(% of total) in Least developed countries in 2001 to that in 2003?
Offer a terse response. 0.16. What is the ratio of the Electricity production(% of total) in United Kingdom in 2001 to that in 2003?
Ensure brevity in your answer.  0.98. What is the ratio of the Electricity production(% of total) of High income in 2001 to that in 2004?
Keep it short and to the point. 1.01. What is the ratio of the Electricity production(% of total) of Least developed countries in 2001 to that in 2004?
Give a very brief answer. 0.25. What is the ratio of the Electricity production(% of total) of Kazakhstan in 2001 to that in 2004?
Keep it short and to the point. 0.94. What is the ratio of the Electricity production(% of total) in United Kingdom in 2001 to that in 2004?
Provide a short and direct response. 1.02. What is the ratio of the Electricity production(% of total) in High income in 2001 to that in 2005?
Give a very brief answer. 1.02. What is the ratio of the Electricity production(% of total) in Least developed countries in 2001 to that in 2005?
Your answer should be very brief. 0.17. What is the ratio of the Electricity production(% of total) of Kazakhstan in 2001 to that in 2005?
Ensure brevity in your answer.  0.96. What is the ratio of the Electricity production(% of total) of United Kingdom in 2001 to that in 2005?
Provide a short and direct response. 1.01. What is the ratio of the Electricity production(% of total) in High income in 2002 to that in 2003?
Keep it short and to the point. 0.98. What is the ratio of the Electricity production(% of total) of Least developed countries in 2002 to that in 2003?
Your answer should be compact. 1.07. What is the ratio of the Electricity production(% of total) of Kazakhstan in 2002 to that in 2003?
Your answer should be very brief. 0.96. What is the ratio of the Electricity production(% of total) of United Kingdom in 2002 to that in 2003?
Provide a short and direct response. 0.92. What is the ratio of the Electricity production(% of total) of High income in 2002 to that in 2004?
Offer a terse response. 1.01. What is the ratio of the Electricity production(% of total) of Least developed countries in 2002 to that in 2004?
Offer a terse response. 1.73. What is the ratio of the Electricity production(% of total) of Kazakhstan in 2002 to that in 2004?
Give a very brief answer. 0.91. What is the ratio of the Electricity production(% of total) of United Kingdom in 2002 to that in 2004?
Provide a short and direct response. 0.96. What is the ratio of the Electricity production(% of total) of High income in 2002 to that in 2005?
Provide a succinct answer. 1.02. What is the ratio of the Electricity production(% of total) in Least developed countries in 2002 to that in 2005?
Give a very brief answer. 1.17. What is the ratio of the Electricity production(% of total) of Kazakhstan in 2002 to that in 2005?
Your answer should be compact. 0.93. What is the ratio of the Electricity production(% of total) of United Kingdom in 2002 to that in 2005?
Make the answer very short. 0.95. What is the ratio of the Electricity production(% of total) of High income in 2003 to that in 2004?
Your answer should be compact. 1.03. What is the ratio of the Electricity production(% of total) in Least developed countries in 2003 to that in 2004?
Offer a very short reply. 1.62. What is the ratio of the Electricity production(% of total) of Kazakhstan in 2003 to that in 2004?
Your answer should be very brief. 0.95. What is the ratio of the Electricity production(% of total) in United Kingdom in 2003 to that in 2004?
Give a very brief answer. 1.04. What is the ratio of the Electricity production(% of total) of High income in 2003 to that in 2005?
Your answer should be compact. 1.03. What is the ratio of the Electricity production(% of total) in Least developed countries in 2003 to that in 2005?
Keep it short and to the point. 1.09. What is the ratio of the Electricity production(% of total) of Kazakhstan in 2003 to that in 2005?
Your response must be concise. 0.97. What is the ratio of the Electricity production(% of total) of United Kingdom in 2003 to that in 2005?
Ensure brevity in your answer.  1.03. What is the ratio of the Electricity production(% of total) of High income in 2004 to that in 2005?
Provide a succinct answer. 1.01. What is the ratio of the Electricity production(% of total) in Least developed countries in 2004 to that in 2005?
Provide a short and direct response. 0.68. What is the ratio of the Electricity production(% of total) in Kazakhstan in 2004 to that in 2005?
Keep it short and to the point. 1.02. What is the ratio of the Electricity production(% of total) in United Kingdom in 2004 to that in 2005?
Provide a succinct answer. 0.99. What is the difference between the highest and the second highest Electricity production(% of total) of High income?
Make the answer very short. 0.14. What is the difference between the highest and the second highest Electricity production(% of total) in Least developed countries?
Provide a succinct answer. 0.05. What is the difference between the highest and the second highest Electricity production(% of total) of Kazakhstan?
Your response must be concise. 1.67. What is the difference between the highest and the second highest Electricity production(% of total) in United Kingdom?
Make the answer very short. 0.56. What is the difference between the highest and the lowest Electricity production(% of total) in High income?
Offer a very short reply. 1.37. What is the difference between the highest and the lowest Electricity production(% of total) of Least developed countries?
Your answer should be compact. 0.73. What is the difference between the highest and the lowest Electricity production(% of total) in Kazakhstan?
Your response must be concise. 6.7. What is the difference between the highest and the lowest Electricity production(% of total) in United Kingdom?
Provide a succinct answer. 5.7. 